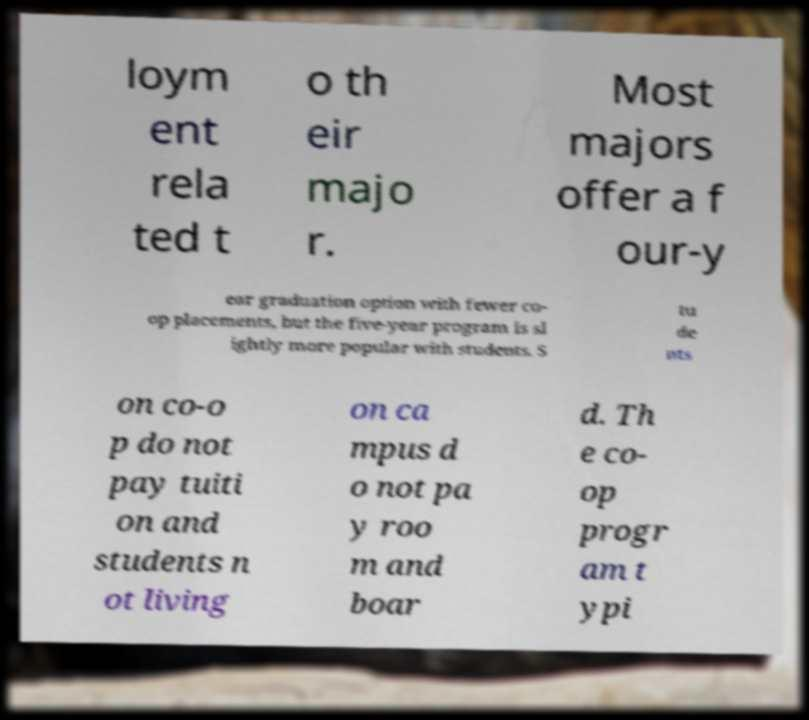For documentation purposes, I need the text within this image transcribed. Could you provide that? loym ent rela ted t o th eir majo r. Most majors offer a f our-y ear graduation option with fewer co- op placements, but the five-year program is sl ightly more popular with students. S tu de nts on co-o p do not pay tuiti on and students n ot living on ca mpus d o not pa y roo m and boar d. Th e co- op progr am t ypi 